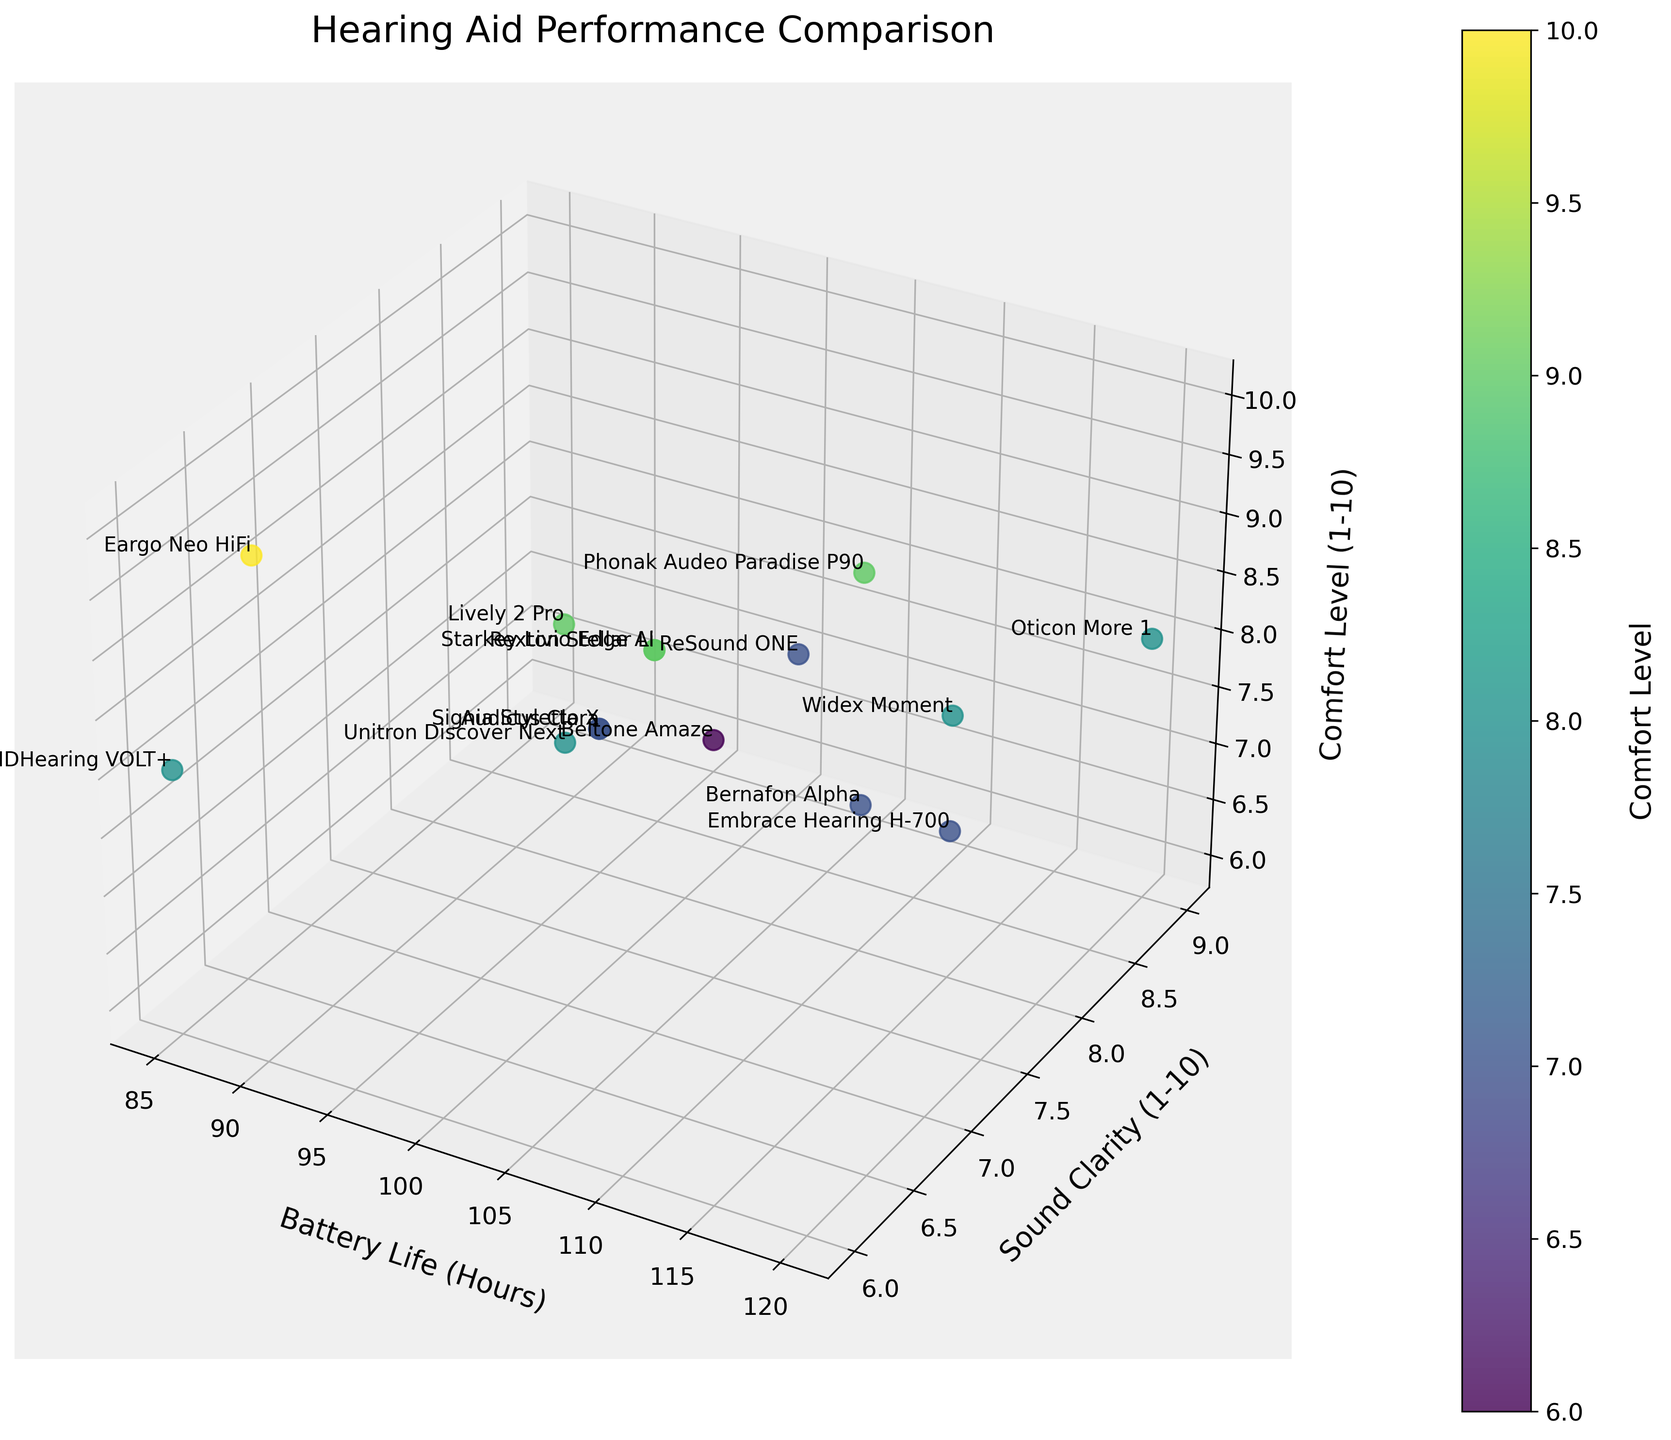Which hearing aid has the longest battery life? By observing the x-axis labeled 'Battery Life (Hours)', the Oticon More 1 model has the longest battery life of 120 hours.
Answer: Oticon More 1 What is the title of the plot? The title is located at the top center of the plot and is labeled "Hearing Aid Performance Comparison".
Answer: Hearing Aid Performance Comparison How many hearing aid models are compared in the plot? Counting the number of data points shown in the scatter plot, there are a total of 15 hearing aid models.
Answer: 15 What are the ranges for the Sound Clarity and Comfort Level axes? The y-axis for 'Sound Clarity (1-10)' ranges from 6 to 9, and the z-axis for 'Comfort Level (1-10)' ranges from 6 to 10.
Answer: Sound Clarity: 6-9, Comfort Level: 6-10 Which model has the highest Comfort Level? By looking at the maximum value on the z-axis labeled 'Comfort Level (1-10)', Eargo Neo HiFi has the highest Comfort Level of 10.
Answer: Eargo Neo HiFi Which two models have the same Sound Clarity but different Battery Life? Observing the y-axis 'Sound Clarity (1-10)', Oticon More 1 and ReSound ONE both have a Sound Clarity of 9 but different Battery Life of 120 and 100 hours, respectively.
Answer: Oticon More 1 and ReSound ONE What is the average Comfort Level of all hearing aids compared? Summing all the Comfort Levels (8, 9, 7, 8, 9, 7, 8, 7, 6, 9, 10, 7, 8, 9, 7) results in 110. Dividing by the 15 models gives an average Comfort Level of 110/15 ≈ 7.33.
Answer: 7.33 Which hearing aid has the lowest Sound Clarity? The lowest value on the y-axis 'Sound Clarity (1-10)' is 6, which corresponds to Eargo Neo HiFi and MDHearing VOLT+.
Answer: Eargo Neo HiFi and MDHearing VOLT+ What is the battery life difference between the model with highest Sound Clarity and the model with highest Comfort Level? The Oticon More 1 has the highest Sound Clarity (9) with a battery life of 120 hours, and the Eargo Neo HiFi has the highest Comfort Level (10) with a battery life of 90 hours. The difference is 120 - 90 = 30 hours.
Answer: 30 hours Compare the Comfort Levels between Phonak Audeo Paradise P90 and Widex Moment. Phonak Audeo Paradise P90 has a Comfort Level of 9, while Widex Moment has a Comfort Level of 8, making Phonak Audeo Paradise P90 more comfortable.
Answer: Phonak Audeo Paradise P90 